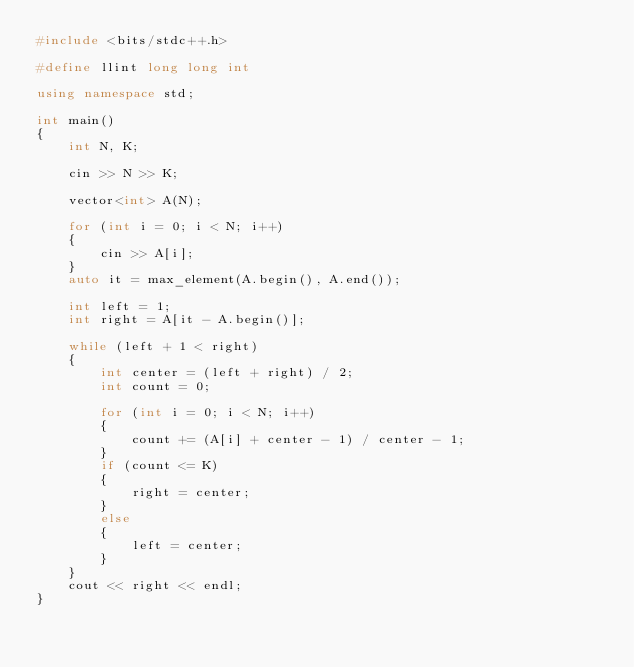Convert code to text. <code><loc_0><loc_0><loc_500><loc_500><_C++_>#include <bits/stdc++.h>

#define llint long long int

using namespace std;

int main()
{
    int N, K;

    cin >> N >> K;

    vector<int> A(N);

    for (int i = 0; i < N; i++)
    {
        cin >> A[i];
    }
    auto it = max_element(A.begin(), A.end());

    int left = 1;
    int right = A[it - A.begin()];

    while (left + 1 < right)
    {
        int center = (left + right) / 2;
        int count = 0;

        for (int i = 0; i < N; i++)
        {
            count += (A[i] + center - 1) / center - 1;
        }
        if (count <= K)
        {
            right = center;
        }
        else
        {
            left = center;
        }
    }
    cout << right << endl;
}</code> 